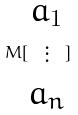<formula> <loc_0><loc_0><loc_500><loc_500>M [ \begin{matrix} a _ { 1 } \\ \vdots \\ a _ { n } \end{matrix} ]</formula> 